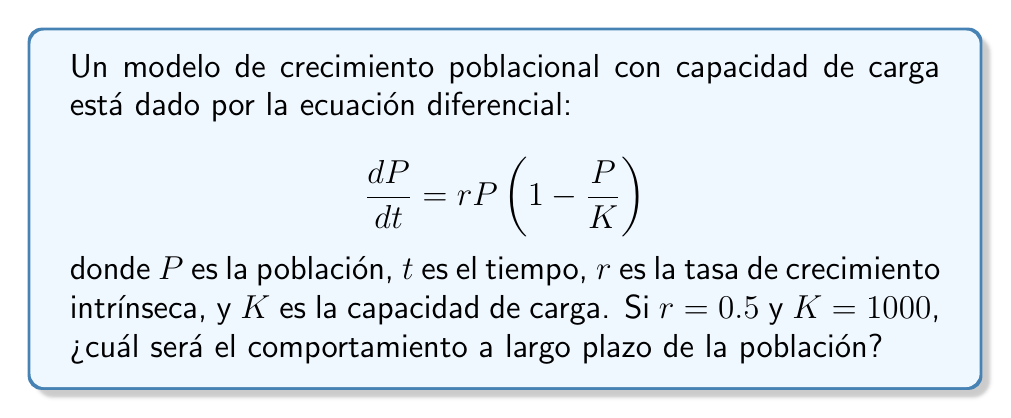What is the answer to this math problem? Para determinar el comportamiento a largo plazo de este modelo de población, seguiremos estos pasos:

1) Primero, identifiquemos los puntos de equilibrio del sistema. Estos ocurren cuando $\frac{dP}{dt} = 0$:

   $$0 = rP\left(1 - \frac{P}{K}\right)$$

2) Resolviendo esta ecuación:
   
   $P = 0$ o $P = K$

3) Por lo tanto, tenemos dos puntos de equilibrio: $P = 0$ y $P = 1000$.

4) Para determinar la estabilidad de estos puntos, analizamos el comportamiento cerca de cada uno:

   - Cerca de $P = 0$, la población crecerá ya que $\frac{dP}{dt} > 0$ para $P$ pequeño.
   - Cerca de $P = 1000$, si $P < 1000$, entonces $\frac{dP}{dt} > 0$ y la población crecerá.
     Si $P > 1000$, entonces $\frac{dP}{dt} < 0$ y la población disminuirá.

5) Esto indica que $P = 0$ es un punto de equilibrio inestable, mientras que $P = 1000$ es un punto de equilibrio estable.

6) El comportamiento a largo plazo de cualquier población inicial positiva será converger hacia el punto de equilibrio estable, $P = 1000$.

Por lo tanto, independientemente de la población inicial (siempre que sea mayor que cero), la población convergerá a la capacidad de carga $K = 1000$ a largo plazo.
Answer: La población convergerá a 1000. 